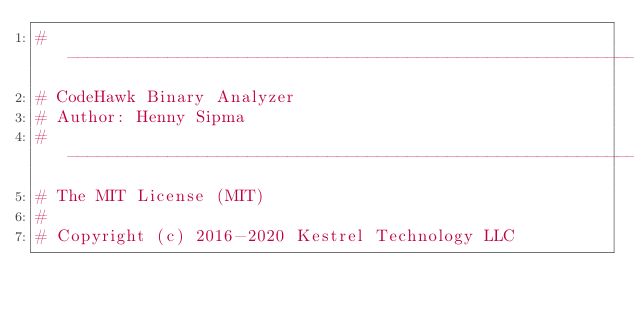<code> <loc_0><loc_0><loc_500><loc_500><_Python_># ------------------------------------------------------------------------------
# CodeHawk Binary Analyzer
# Author: Henny Sipma
# ------------------------------------------------------------------------------
# The MIT License (MIT)
#
# Copyright (c) 2016-2020 Kestrel Technology LLC</code> 